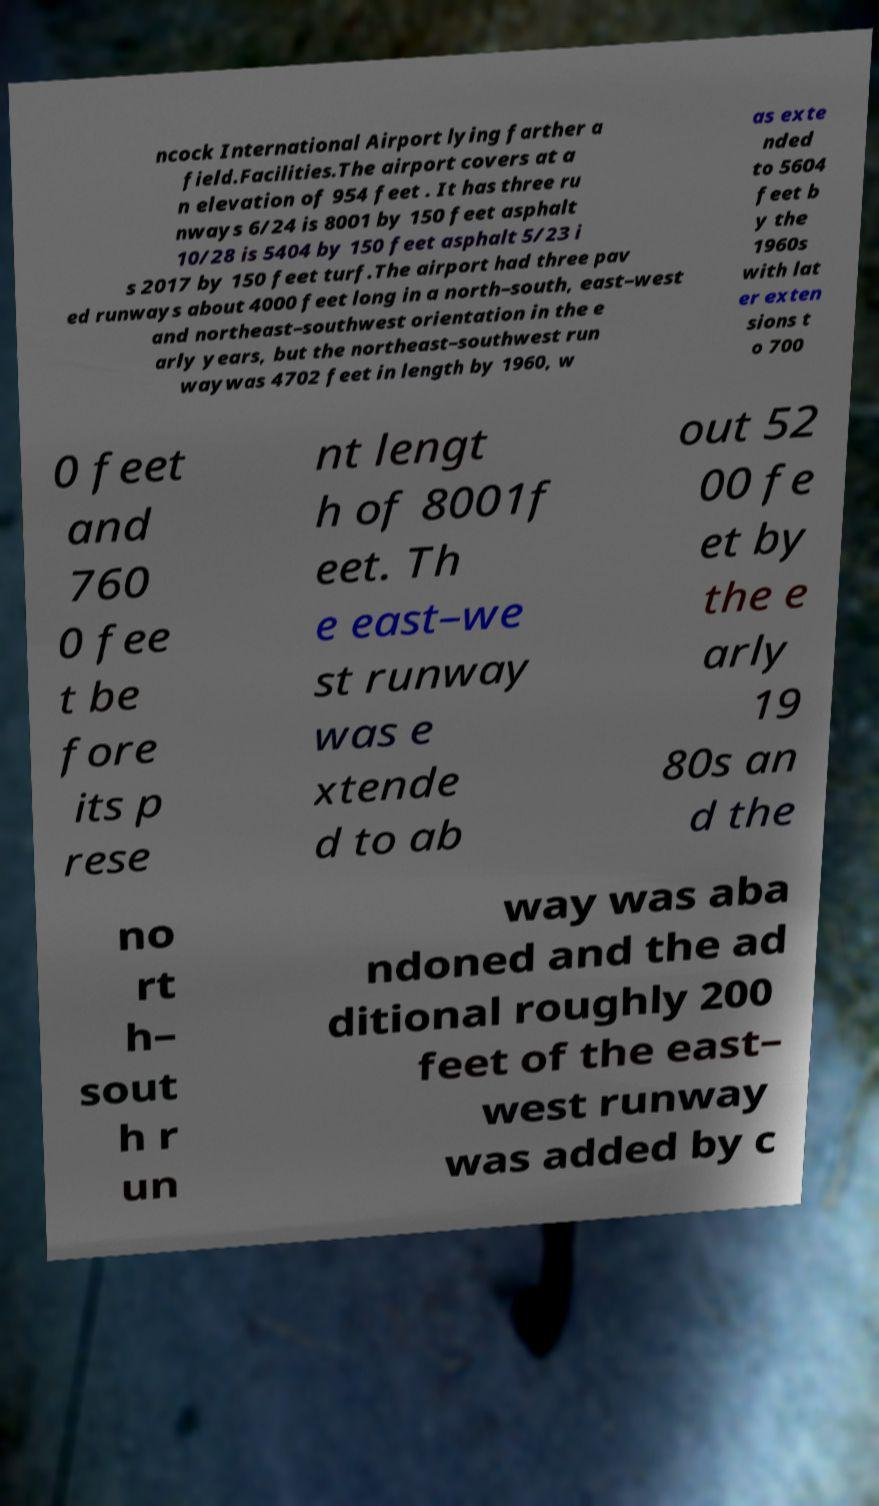Please read and relay the text visible in this image. What does it say? ncock International Airport lying farther a field.Facilities.The airport covers at a n elevation of 954 feet . It has three ru nways 6/24 is 8001 by 150 feet asphalt 10/28 is 5404 by 150 feet asphalt 5/23 i s 2017 by 150 feet turf.The airport had three pav ed runways about 4000 feet long in a north–south, east–west and northeast–southwest orientation in the e arly years, but the northeast–southwest run waywas 4702 feet in length by 1960, w as exte nded to 5604 feet b y the 1960s with lat er exten sions t o 700 0 feet and 760 0 fee t be fore its p rese nt lengt h of 8001f eet. Th e east–we st runway was e xtende d to ab out 52 00 fe et by the e arly 19 80s an d the no rt h– sout h r un way was aba ndoned and the ad ditional roughly 200 feet of the east– west runway was added by c 